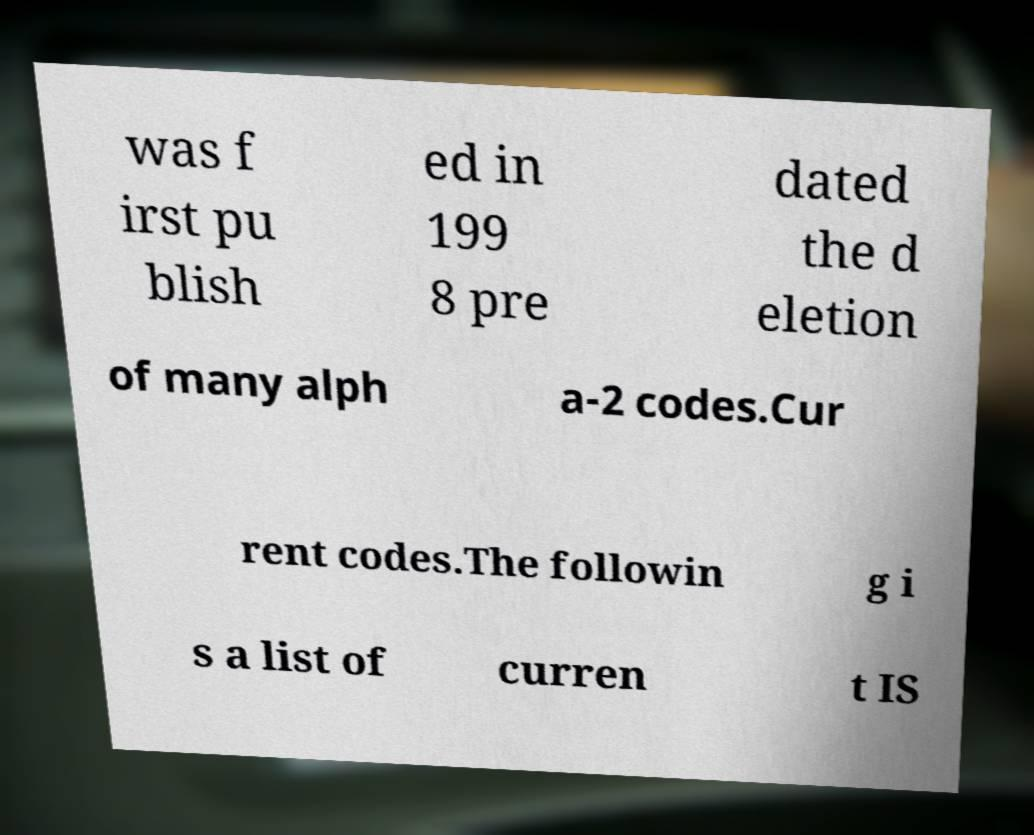Can you read and provide the text displayed in the image?This photo seems to have some interesting text. Can you extract and type it out for me? was f irst pu blish ed in 199 8 pre dated the d eletion of many alph a-2 codes.Cur rent codes.The followin g i s a list of curren t IS 